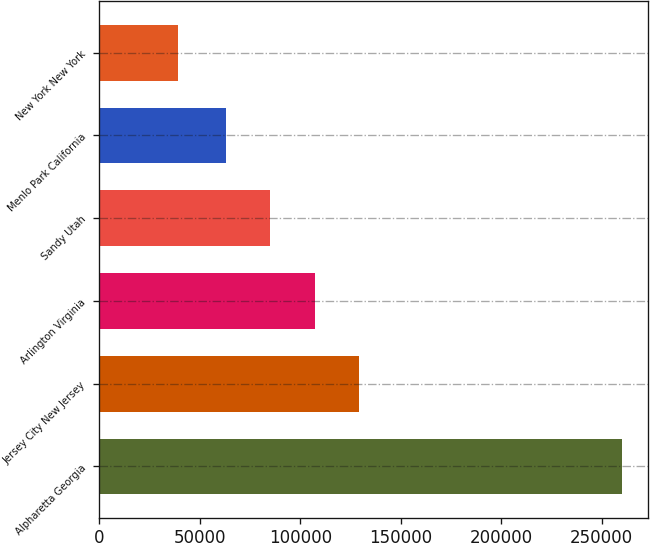<chart> <loc_0><loc_0><loc_500><loc_500><bar_chart><fcel>Alpharetta Georgia<fcel>Jersey City New Jersey<fcel>Arlington Virginia<fcel>Sandy Utah<fcel>Menlo Park California<fcel>New York New York<nl><fcel>260000<fcel>129300<fcel>107200<fcel>85100<fcel>63000<fcel>39000<nl></chart> 